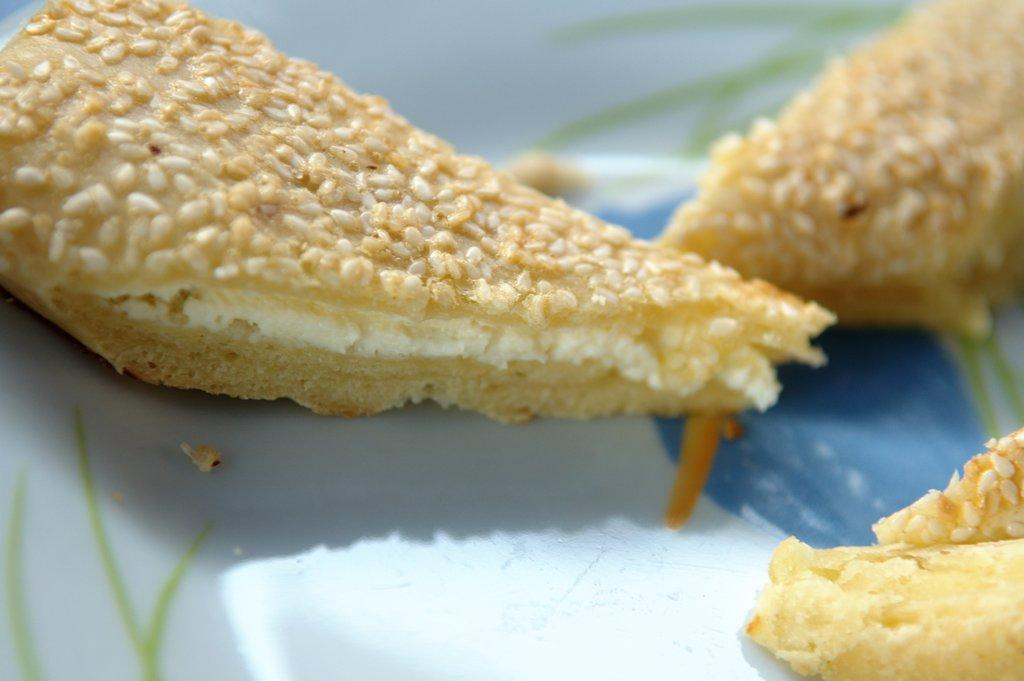What is present on both sides of the image? There are toasts on both the right and left sides of the image. Can you describe the positioning of the toasts in the image? The toasts are on both sides of the image, with some on the right and some on the left. What type of cord is being used to hold the toasts together in the image? There is no cord present in the image; the toasts are not connected or held together. 